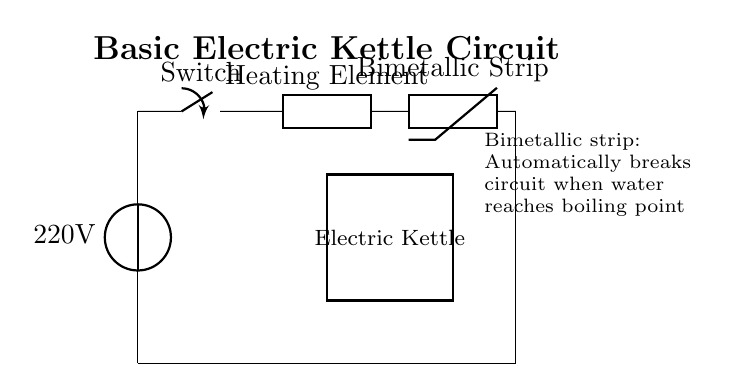What is the voltage of this circuit? The voltage is 220 volts, indicated next to the power source in the circuit diagram. This represents the input voltage supplied to the electric kettle.
Answer: 220 volts What component is responsible for heating the water? The heating element is responsible for heating the water. In the diagram, it is labeled as the "Heating Element," which implies its function in the circuit.
Answer: Heating Element What does the bimetallic strip do? The bimetallic strip automatically breaks the circuit when the water reaches the boiling point. This is indicated in the additional explanation next to the strip in the diagram, detailing its functionality in relation to temperature.
Answer: Automatically breaks circuit How does the circuit return to the power source? The circuit returns to the power source via a direct connection from the bimetallic strip, moving down vertically and then horizontally back to the starting point. This connection is shown as a continuous line in the diagram.
Answer: Direct connection What is the function of the switch in the circuit? The switch controls the flow of electricity to the kettle and allows the user to turn the kettle on or off. It's depicted in the upper part of the circuit diagram, linked to the power source and heating element.
Answer: Control flow of electricity Which component is placed after the heating element? The component placed after the heating element is the bimetallic strip. In the circuit diagram, the sequence of components is clear, with the bimetallic strip directly following the heating element.
Answer: Bimetallic Strip 